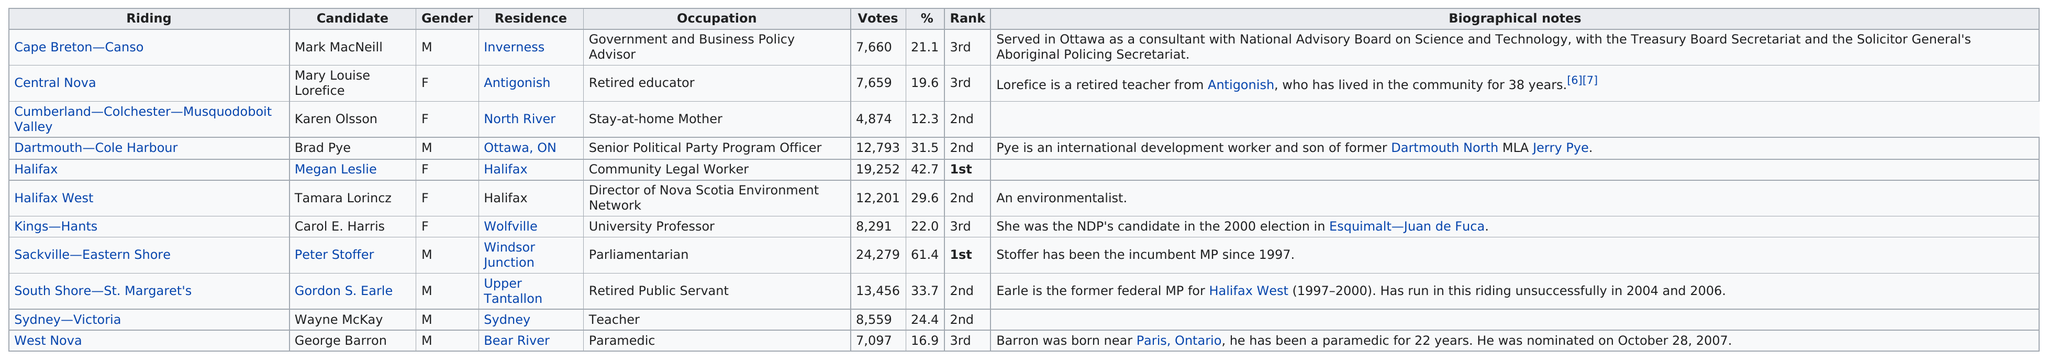Indicate a few pertinent items in this graphic. Mark MacNeill received a greater number of votes than Olsson in the election. Karen Olsson received the least amount of votes among all candidates. Out of all the candidates, it was determined that 5 were females. The total number of votes received by female candidates is 52,277. How many more males were candidates than females? There were 1 male candidates for every X females. 